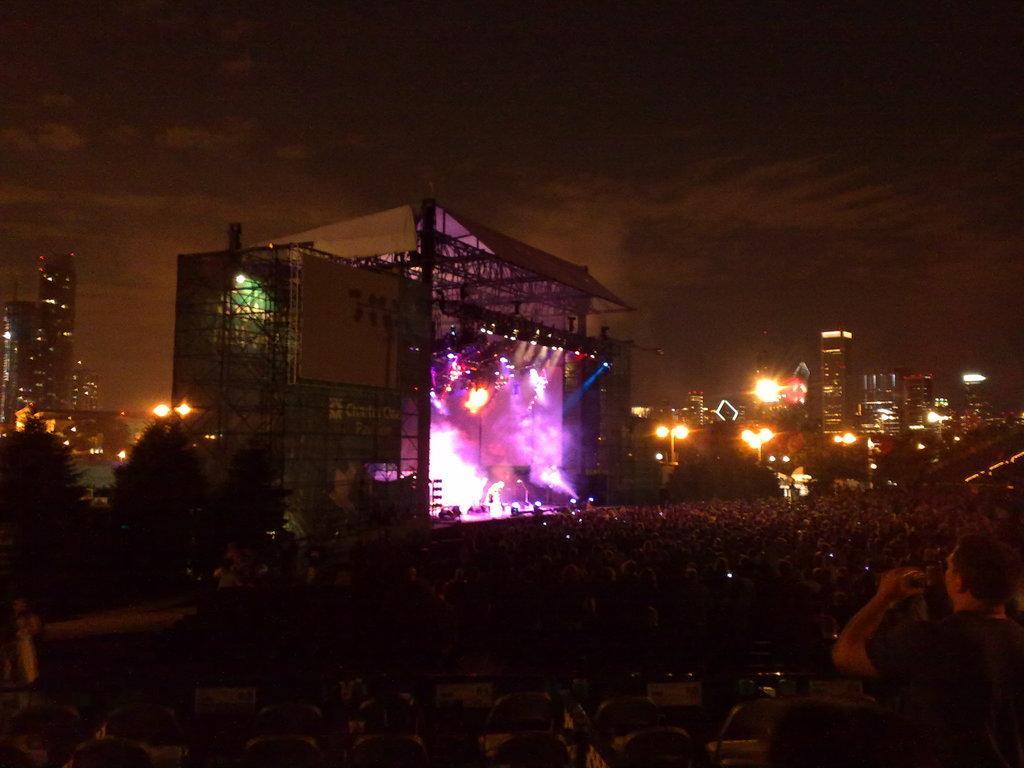Could you give a brief overview of what you see in this image? I can see groups of people standing. This looks like a stage performance. These are the show lights. I can see the buildings. These are the trees. At the bottom of the image, I can see the empty chairs. 